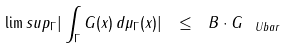<formula> <loc_0><loc_0><loc_500><loc_500>\lim s u p _ { \Gamma } | \int _ { \Gamma } G ( x ) \, d \mu _ { \Gamma } ( x ) | \ \leq \ B \cdot \| G \| _ { \ U b a r }</formula> 